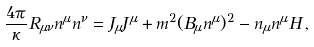<formula> <loc_0><loc_0><loc_500><loc_500>\frac { 4 \pi } \kappa R _ { \mu \nu } n ^ { \mu } n ^ { \nu } = J _ { \mu } J ^ { \mu } + m ^ { 2 } ( B _ { \mu } n ^ { \mu } ) ^ { 2 } - n _ { \mu } n ^ { \mu } H \, ,</formula> 